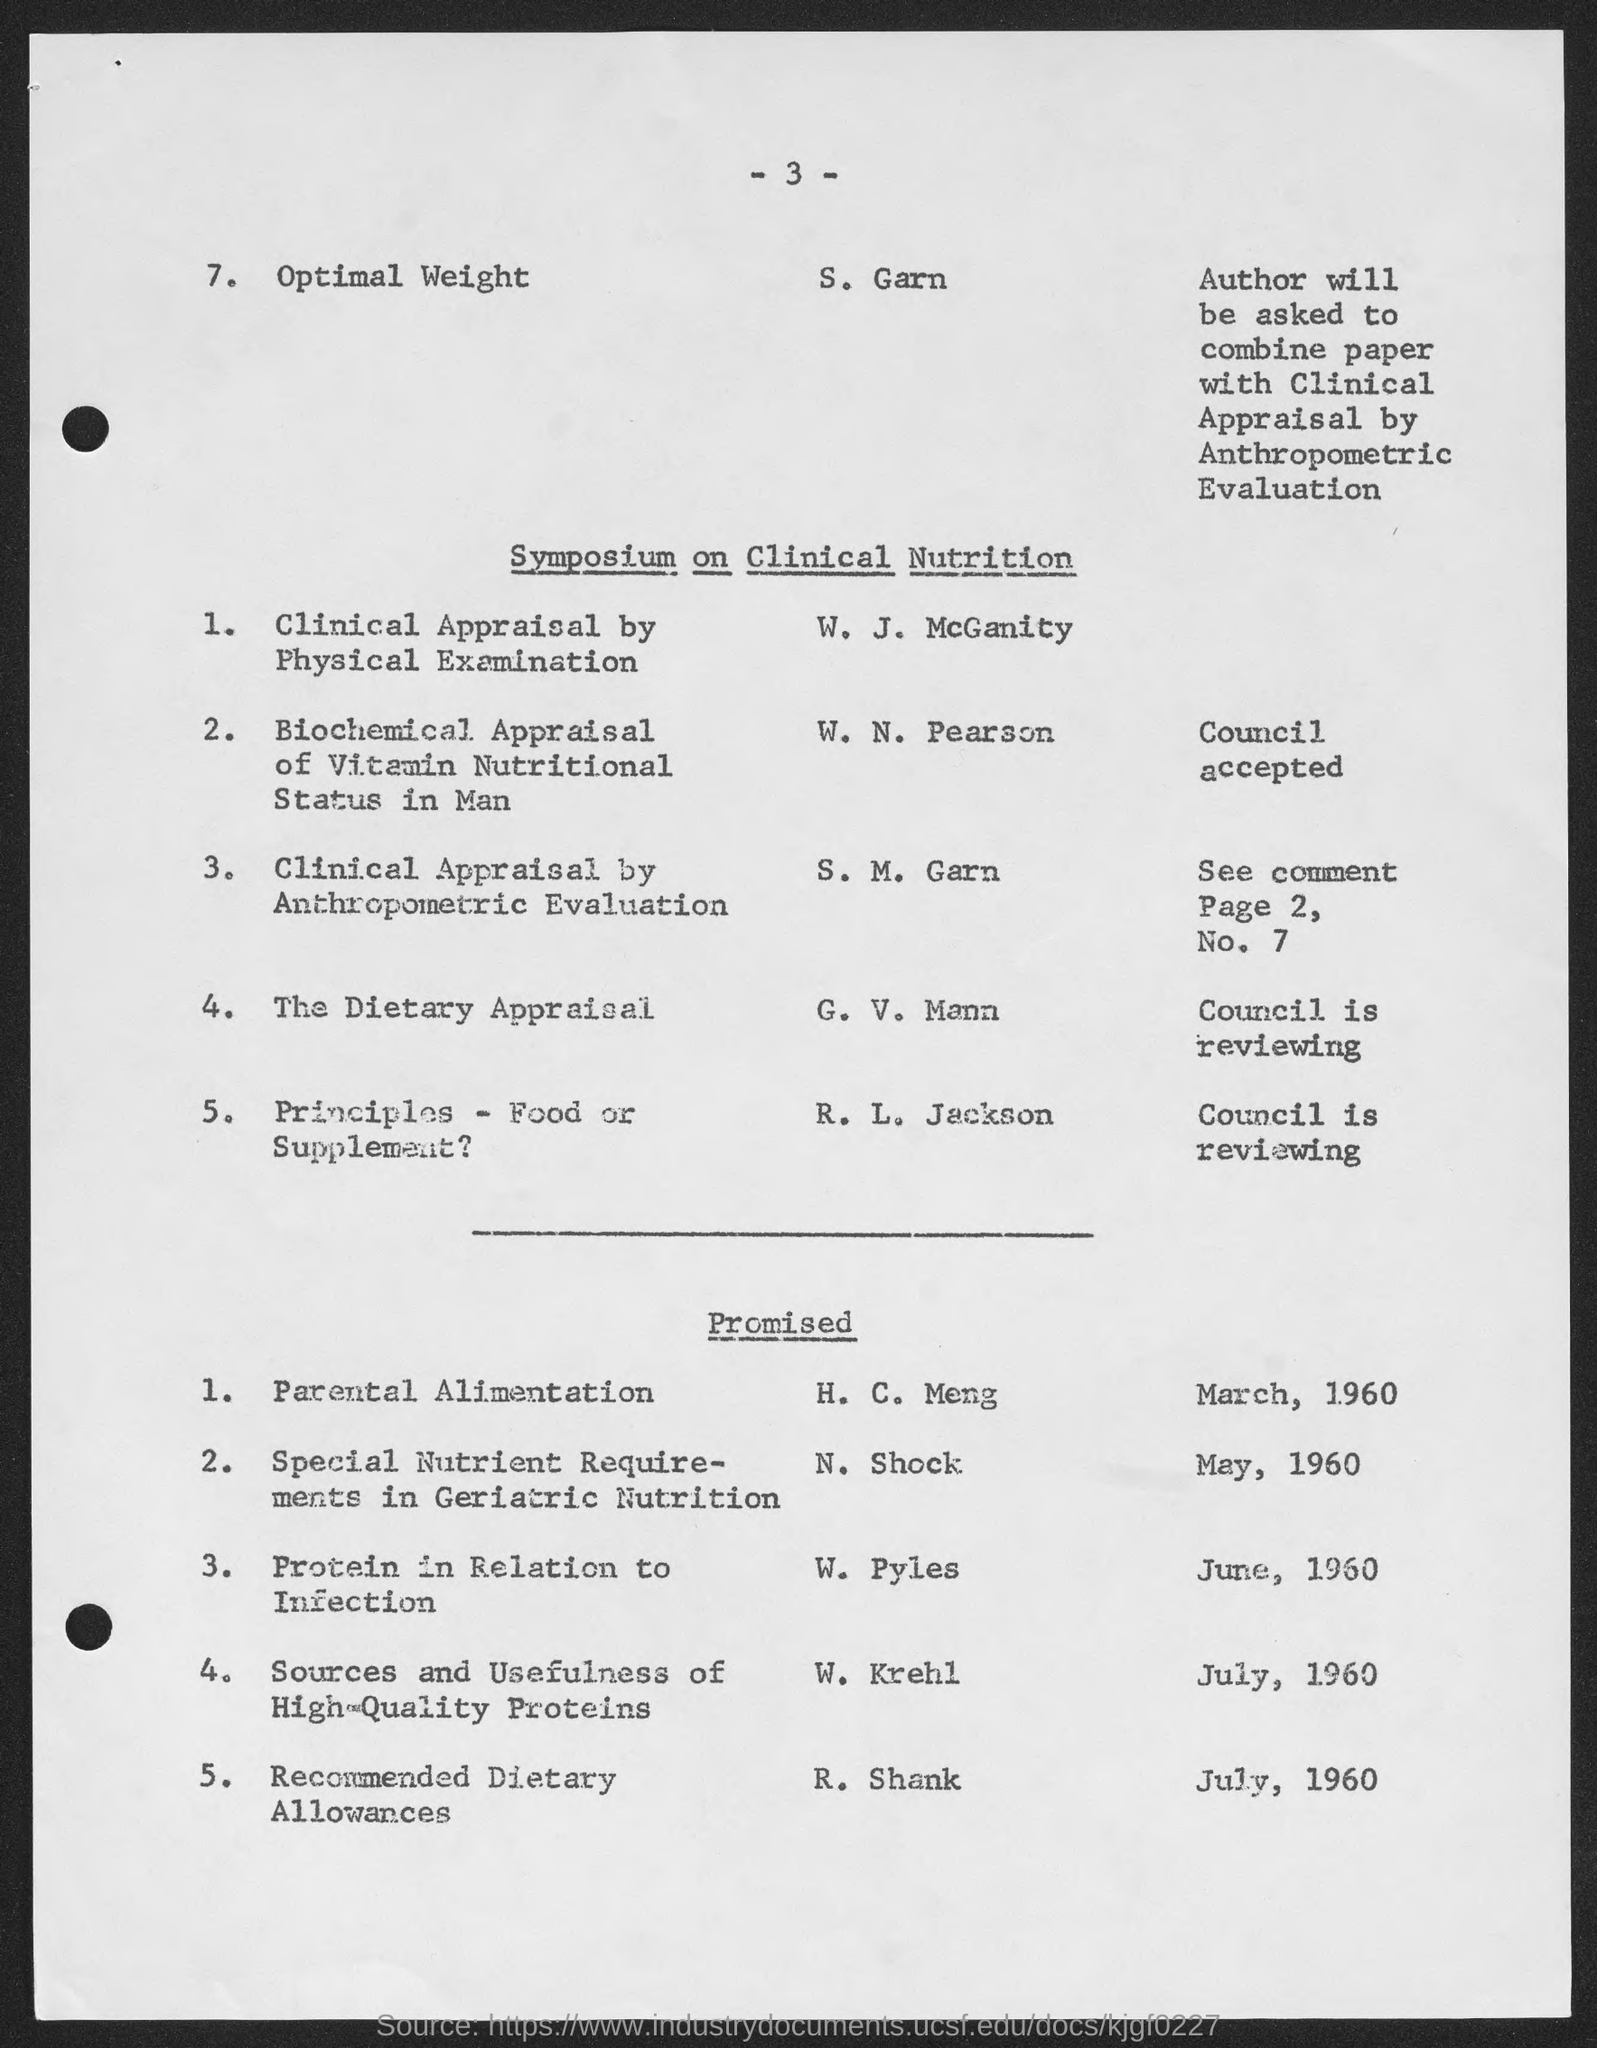Draw attention to some important aspects in this diagram. The number at the top of the page is 3. 